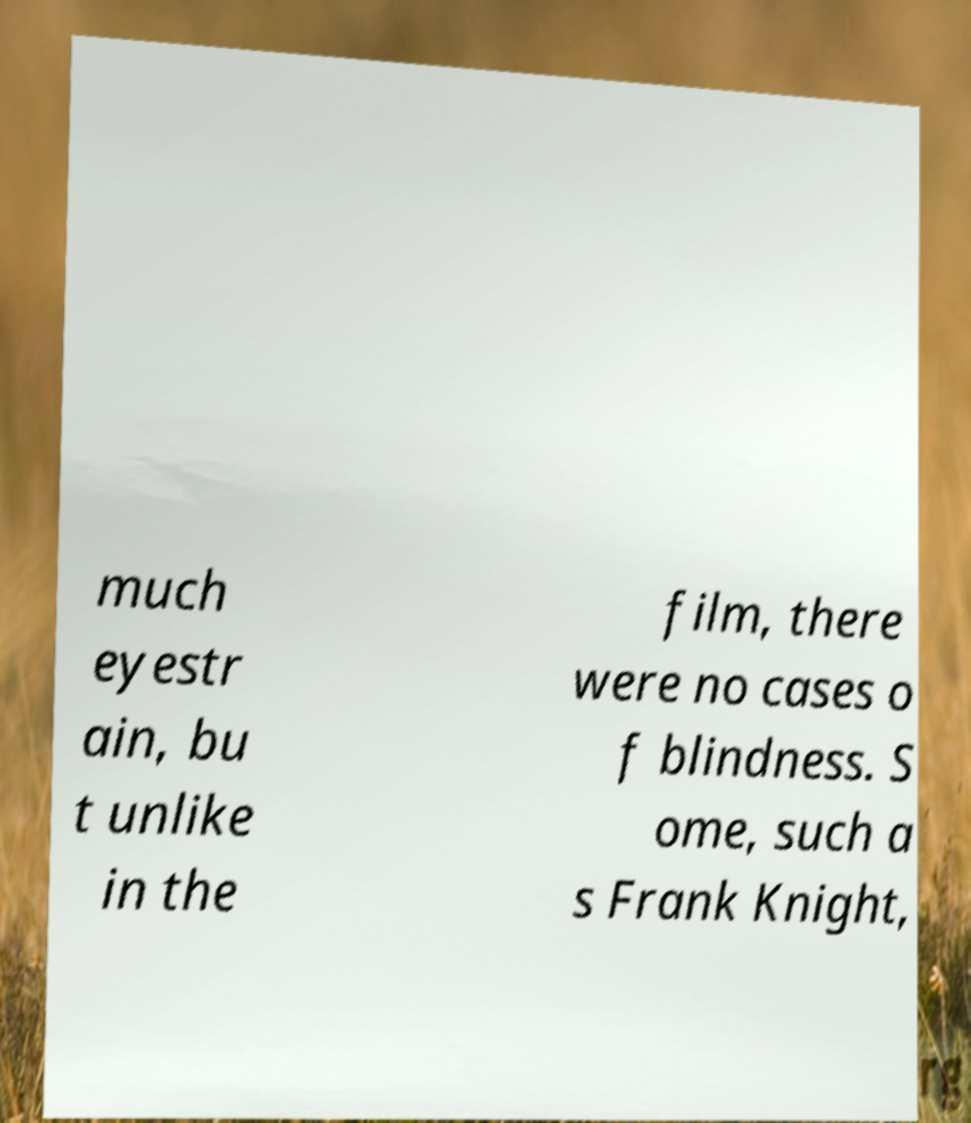For documentation purposes, I need the text within this image transcribed. Could you provide that? much eyestr ain, bu t unlike in the film, there were no cases o f blindness. S ome, such a s Frank Knight, 